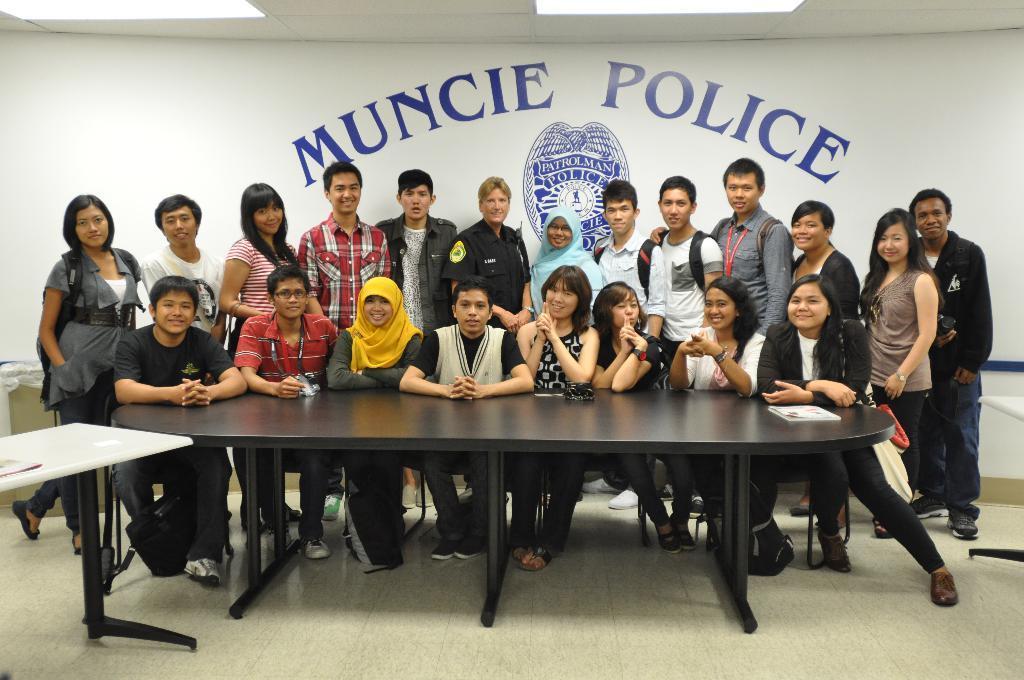How would you summarize this image in a sentence or two? In this picture we can see some people are standing and some people are sitting in front of a table, on the left side we can see another table, in the background there is a wall, we can see some text on the wall. 